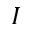<formula> <loc_0><loc_0><loc_500><loc_500>I</formula> 